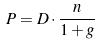<formula> <loc_0><loc_0><loc_500><loc_500>P = D \cdot \frac { n } { 1 + g }</formula> 